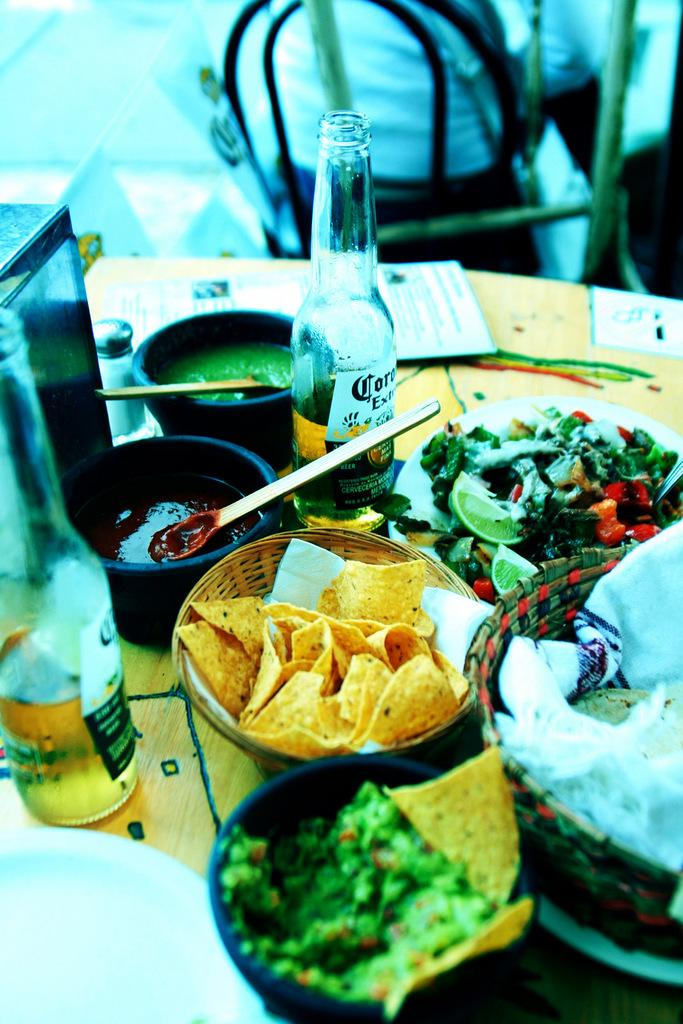<image>
Write a terse but informative summary of the picture. Salsa and chips with a Corona beer half drank on the table. 